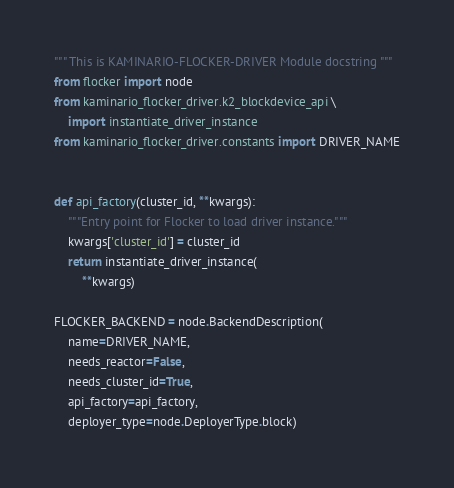<code> <loc_0><loc_0><loc_500><loc_500><_Python_>""" This is KAMINARIO-FLOCKER-DRIVER Module docstring """
from flocker import node
from kaminario_flocker_driver.k2_blockdevice_api \
    import instantiate_driver_instance
from kaminario_flocker_driver.constants import DRIVER_NAME


def api_factory(cluster_id, **kwargs):
    """Entry point for Flocker to load driver instance."""
    kwargs['cluster_id'] = cluster_id
    return instantiate_driver_instance(
        **kwargs)

FLOCKER_BACKEND = node.BackendDescription(
    name=DRIVER_NAME,
    needs_reactor=False,
    needs_cluster_id=True,
    api_factory=api_factory,
    deployer_type=node.DeployerType.block)
</code> 